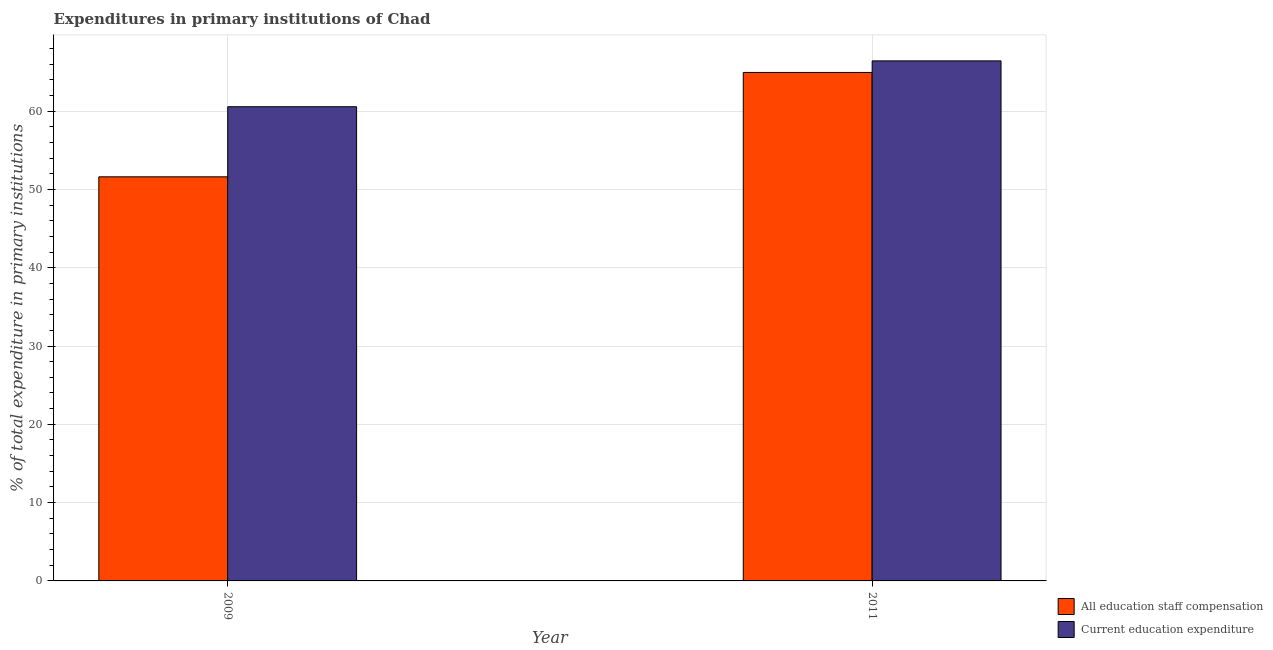Are the number of bars per tick equal to the number of legend labels?
Provide a short and direct response. Yes. Are the number of bars on each tick of the X-axis equal?
Ensure brevity in your answer.  Yes. How many bars are there on the 1st tick from the left?
Provide a short and direct response. 2. How many bars are there on the 2nd tick from the right?
Make the answer very short. 2. What is the expenditure in education in 2011?
Offer a terse response. 66.41. Across all years, what is the maximum expenditure in staff compensation?
Offer a terse response. 64.94. Across all years, what is the minimum expenditure in education?
Ensure brevity in your answer.  60.56. In which year was the expenditure in staff compensation maximum?
Provide a succinct answer. 2011. In which year was the expenditure in staff compensation minimum?
Ensure brevity in your answer.  2009. What is the total expenditure in staff compensation in the graph?
Ensure brevity in your answer.  116.54. What is the difference between the expenditure in staff compensation in 2009 and that in 2011?
Ensure brevity in your answer.  -13.33. What is the difference between the expenditure in staff compensation in 2011 and the expenditure in education in 2009?
Keep it short and to the point. 13.33. What is the average expenditure in staff compensation per year?
Provide a succinct answer. 58.27. In the year 2011, what is the difference between the expenditure in education and expenditure in staff compensation?
Give a very brief answer. 0. What is the ratio of the expenditure in staff compensation in 2009 to that in 2011?
Your response must be concise. 0.79. In how many years, is the expenditure in staff compensation greater than the average expenditure in staff compensation taken over all years?
Ensure brevity in your answer.  1. What does the 2nd bar from the left in 2011 represents?
Ensure brevity in your answer.  Current education expenditure. What does the 1st bar from the right in 2011 represents?
Ensure brevity in your answer.  Current education expenditure. How many bars are there?
Ensure brevity in your answer.  4. Are all the bars in the graph horizontal?
Make the answer very short. No. What is the difference between two consecutive major ticks on the Y-axis?
Provide a short and direct response. 10. Does the graph contain any zero values?
Your answer should be compact. No. How many legend labels are there?
Your answer should be very brief. 2. How are the legend labels stacked?
Offer a very short reply. Vertical. What is the title of the graph?
Give a very brief answer. Expenditures in primary institutions of Chad. What is the label or title of the Y-axis?
Offer a terse response. % of total expenditure in primary institutions. What is the % of total expenditure in primary institutions of All education staff compensation in 2009?
Offer a very short reply. 51.61. What is the % of total expenditure in primary institutions in Current education expenditure in 2009?
Keep it short and to the point. 60.56. What is the % of total expenditure in primary institutions in All education staff compensation in 2011?
Your response must be concise. 64.94. What is the % of total expenditure in primary institutions of Current education expenditure in 2011?
Offer a terse response. 66.41. Across all years, what is the maximum % of total expenditure in primary institutions of All education staff compensation?
Provide a succinct answer. 64.94. Across all years, what is the maximum % of total expenditure in primary institutions in Current education expenditure?
Your answer should be very brief. 66.41. Across all years, what is the minimum % of total expenditure in primary institutions in All education staff compensation?
Offer a terse response. 51.61. Across all years, what is the minimum % of total expenditure in primary institutions in Current education expenditure?
Give a very brief answer. 60.56. What is the total % of total expenditure in primary institutions of All education staff compensation in the graph?
Make the answer very short. 116.54. What is the total % of total expenditure in primary institutions in Current education expenditure in the graph?
Your answer should be compact. 126.97. What is the difference between the % of total expenditure in primary institutions of All education staff compensation in 2009 and that in 2011?
Offer a very short reply. -13.33. What is the difference between the % of total expenditure in primary institutions of Current education expenditure in 2009 and that in 2011?
Provide a short and direct response. -5.86. What is the difference between the % of total expenditure in primary institutions in All education staff compensation in 2009 and the % of total expenditure in primary institutions in Current education expenditure in 2011?
Offer a very short reply. -14.81. What is the average % of total expenditure in primary institutions in All education staff compensation per year?
Keep it short and to the point. 58.27. What is the average % of total expenditure in primary institutions in Current education expenditure per year?
Offer a terse response. 63.48. In the year 2009, what is the difference between the % of total expenditure in primary institutions of All education staff compensation and % of total expenditure in primary institutions of Current education expenditure?
Offer a very short reply. -8.95. In the year 2011, what is the difference between the % of total expenditure in primary institutions in All education staff compensation and % of total expenditure in primary institutions in Current education expenditure?
Keep it short and to the point. -1.48. What is the ratio of the % of total expenditure in primary institutions in All education staff compensation in 2009 to that in 2011?
Offer a very short reply. 0.79. What is the ratio of the % of total expenditure in primary institutions in Current education expenditure in 2009 to that in 2011?
Give a very brief answer. 0.91. What is the difference between the highest and the second highest % of total expenditure in primary institutions in All education staff compensation?
Ensure brevity in your answer.  13.33. What is the difference between the highest and the second highest % of total expenditure in primary institutions of Current education expenditure?
Provide a short and direct response. 5.86. What is the difference between the highest and the lowest % of total expenditure in primary institutions in All education staff compensation?
Give a very brief answer. 13.33. What is the difference between the highest and the lowest % of total expenditure in primary institutions of Current education expenditure?
Your answer should be compact. 5.86. 